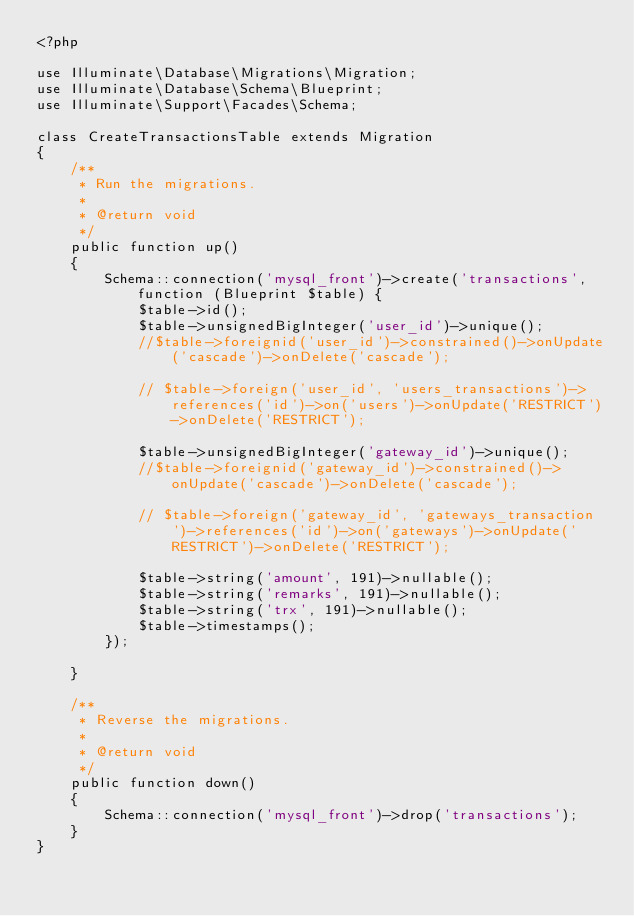Convert code to text. <code><loc_0><loc_0><loc_500><loc_500><_PHP_><?php

use Illuminate\Database\Migrations\Migration;
use Illuminate\Database\Schema\Blueprint;
use Illuminate\Support\Facades\Schema;

class CreateTransactionsTable extends Migration
{
    /**
     * Run the migrations.
     *
     * @return void
     */
    public function up()
    {
        Schema::connection('mysql_front')->create('transactions', function (Blueprint $table) {
            $table->id();
            $table->unsignedBigInteger('user_id')->unique();
            //$table->foreignid('user_id')->constrained()->onUpdate('cascade')->onDelete('cascade');

            // $table->foreign('user_id', 'users_transactions')->references('id')->on('users')->onUpdate('RESTRICT')->onDelete('RESTRICT');

            $table->unsignedBigInteger('gateway_id')->unique();
            //$table->foreignid('gateway_id')->constrained()->onUpdate('cascade')->onDelete('cascade');

            // $table->foreign('gateway_id', 'gateways_transaction')->references('id')->on('gateways')->onUpdate('RESTRICT')->onDelete('RESTRICT');

            $table->string('amount', 191)->nullable();
            $table->string('remarks', 191)->nullable();
            $table->string('trx', 191)->nullable();
            $table->timestamps();
        });

    }

    /**
     * Reverse the migrations.
     *
     * @return void
     */
    public function down()
    {
        Schema::connection('mysql_front')->drop('transactions');
    }
}
</code> 